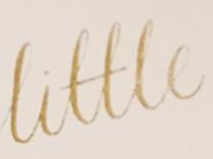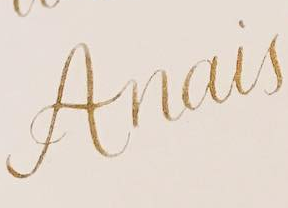What text is displayed in these images sequentially, separated by a semicolon? Little; Anais 